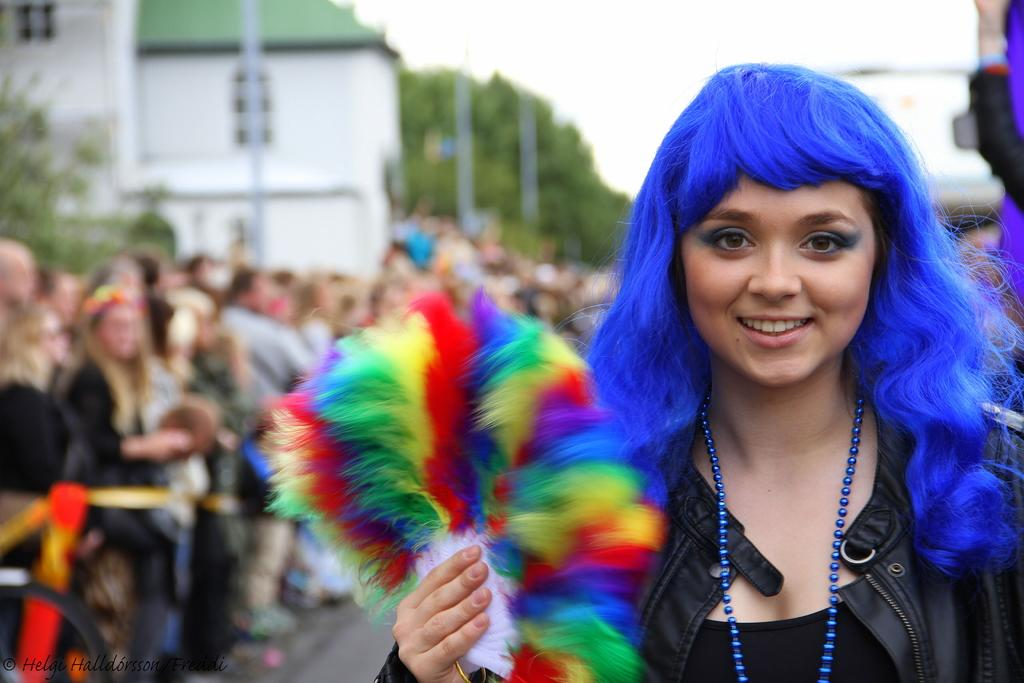What is the main subject of the image? There is a woman in the image. What is the woman holding in the image? The woman is holding an object. Can you describe the people behind the woman? There are people standing behind the woman. What can be seen in the background of the image? Buildings, trees, and the sky are visible in the background. What type of gold paste is visible on the woman's face in the image? There is no gold paste visible on the woman's face in the image. How does the woman move in the image? The image is a still photograph, so the woman is not moving. 